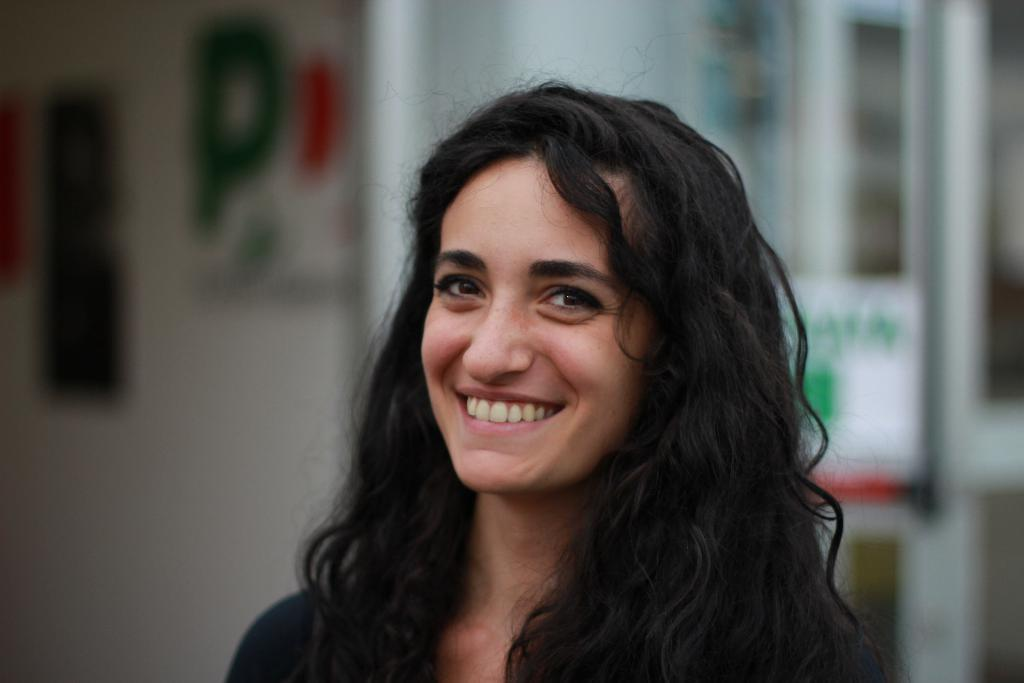Who is present in the image? There is a woman in the image. What is the woman's facial expression? The woman is smiling. Can you describe the background of the image? The background of the image is blurred. Is there a person in the image trying to sell produce? There is no person in the image trying to sell produce; the image only features a woman who is smiling. 